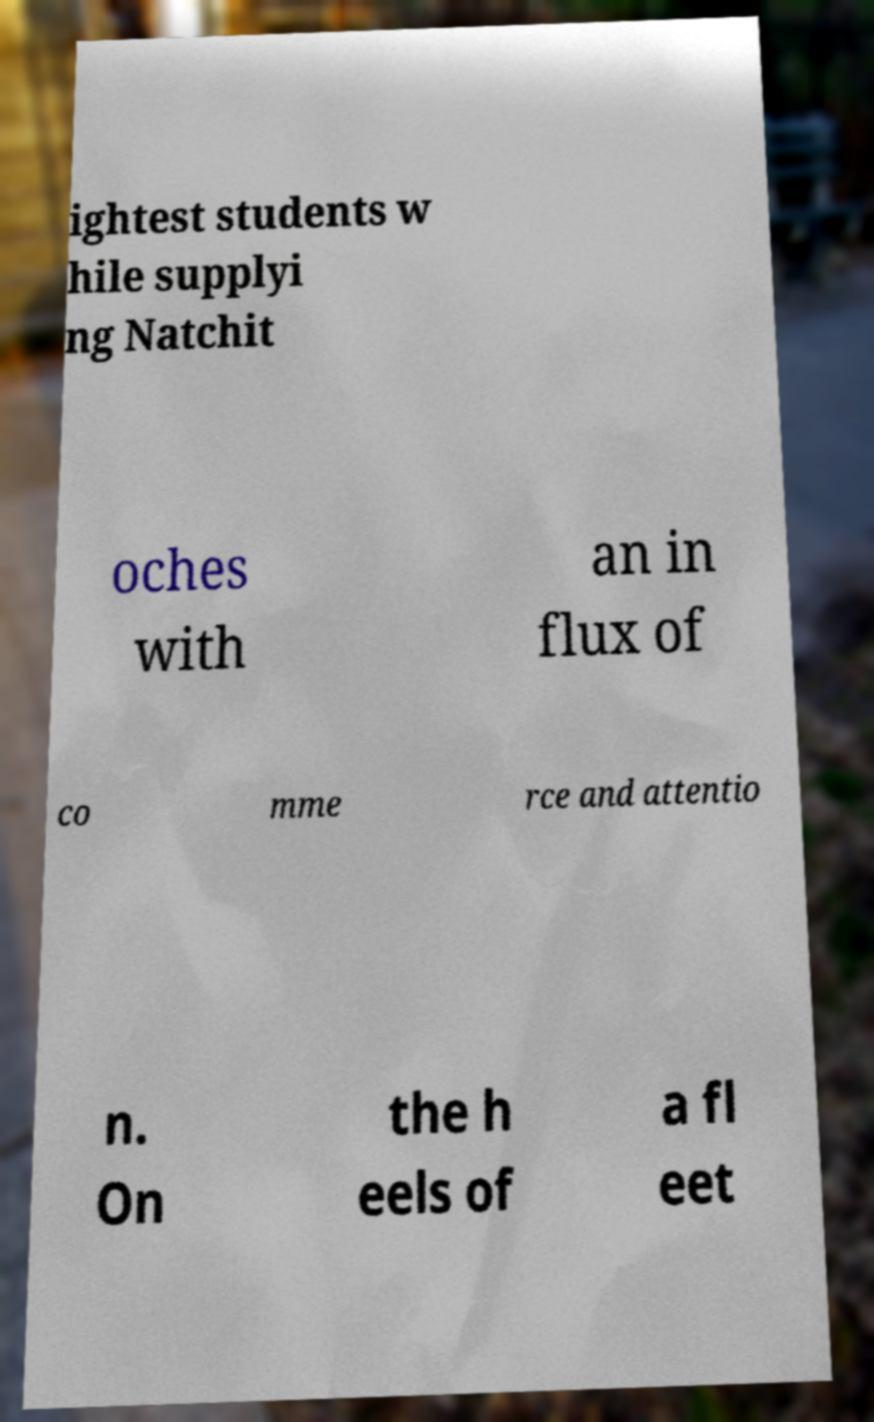What messages or text are displayed in this image? I need them in a readable, typed format. ightest students w hile supplyi ng Natchit oches with an in flux of co mme rce and attentio n. On the h eels of a fl eet 